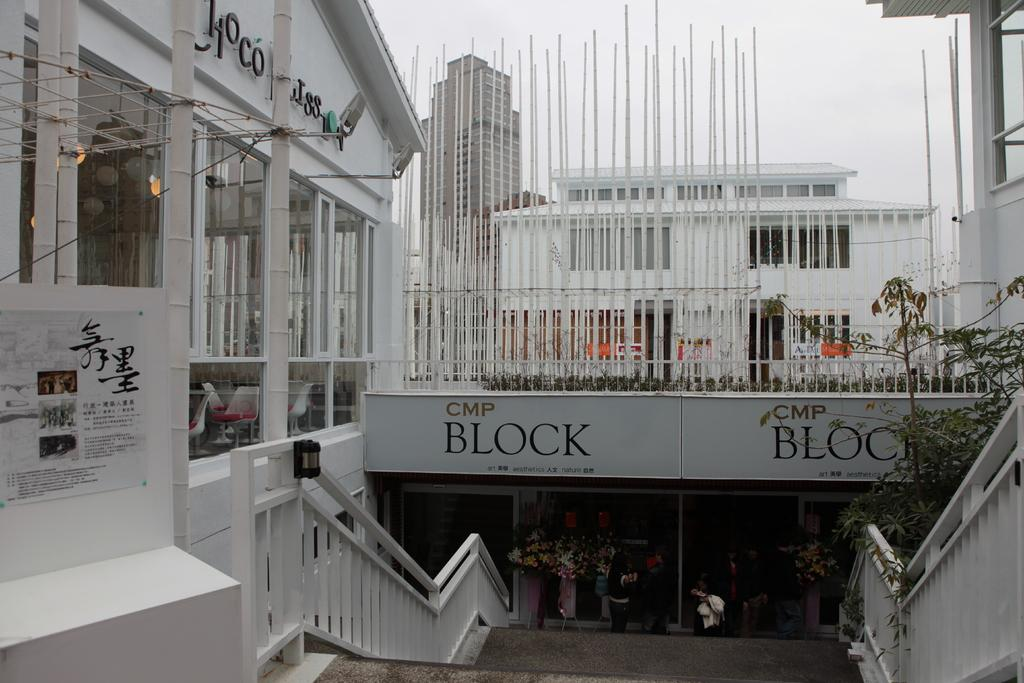What type of structures can be seen in the image? There are buildings in the image. What architectural feature is present at the bottom of the image? There are stairs at the bottom of the image. What can be found in the middle of the image? There are grills in the middle of the image. What is visible at the top of the image? There is a sky at the top of the image. How many hens are sitting on the grills in the image? There are no hens present in the image; it features buildings, stairs, grills, and a sky. What type of ring can be seen on the buildings in the image? There is no ring present on the buildings in the image. 